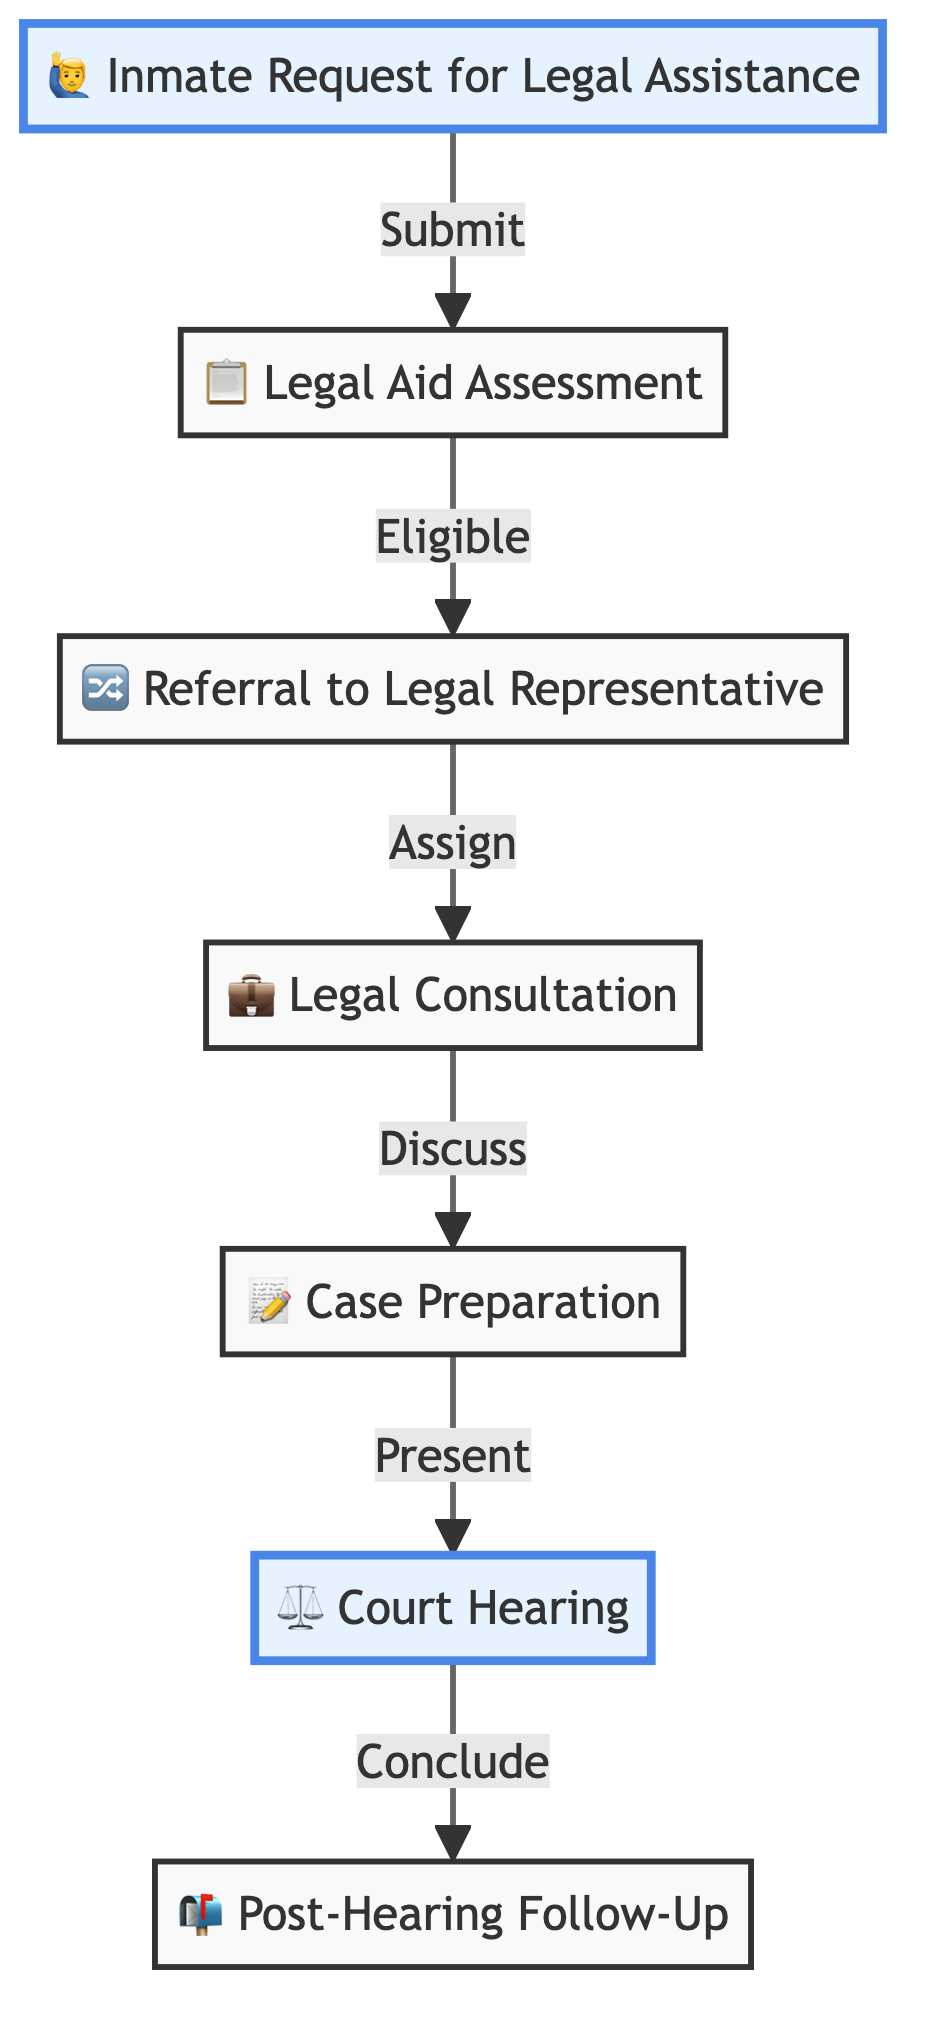What is the first step in the pathway for legal representation? The first step is "Inmate Request for Legal Assistance," where inmates submit a request for legal services.
Answer: Inmate Request for Legal Assistance How many nodes are there in this flow chart? The flow chart has seven nodes, each representing a step in the legal representation process.
Answer: 7 Which node involves the assessment of inmates' eligibility? The node that involves the assessment of inmates' eligibility is "Legal Aid Assessment."
Answer: Legal Aid Assessment What happens after the "Legal Consultation" node? After the "Legal Consultation" node, the next step is "Case Preparation," where attorneys prepare for the case.
Answer: Case Preparation Which step directly follows "Court Hearing"? The step that directly follows "Court Hearing" is "Post-Hearing Follow-Up."
Answer: Post-Hearing Follow-Up What is the relationship between "Legal Aid Assessment" and "Referral to Legal Representative"? The relationship is that if inmates are deemed eligible during the "Legal Aid Assessment," they are then referred to an attorney in the "Referral to Legal Representative" node.
Answer: Eligible What type of activity occurs during the "Legal Consultation"? During the "Legal Consultation," inmates meet with attorneys to discuss their cases and rights.
Answer: Discuss How many steps focus on the court process? There are three steps that focus on the court process: "Court Hearing," "Case Preparation," and "Post-Hearing Follow-Up."
Answer: 3 What does the arrow from "Referral to Legal Representative" indicate? The arrow indicates that eligible inmates are assigned to meet with attorneys for consultation after the referral.
Answer: Assign 